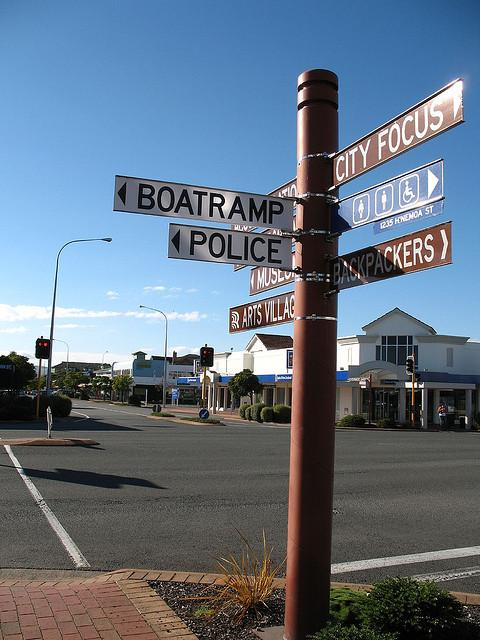What sign should I follow if I have lost my wallet? police 